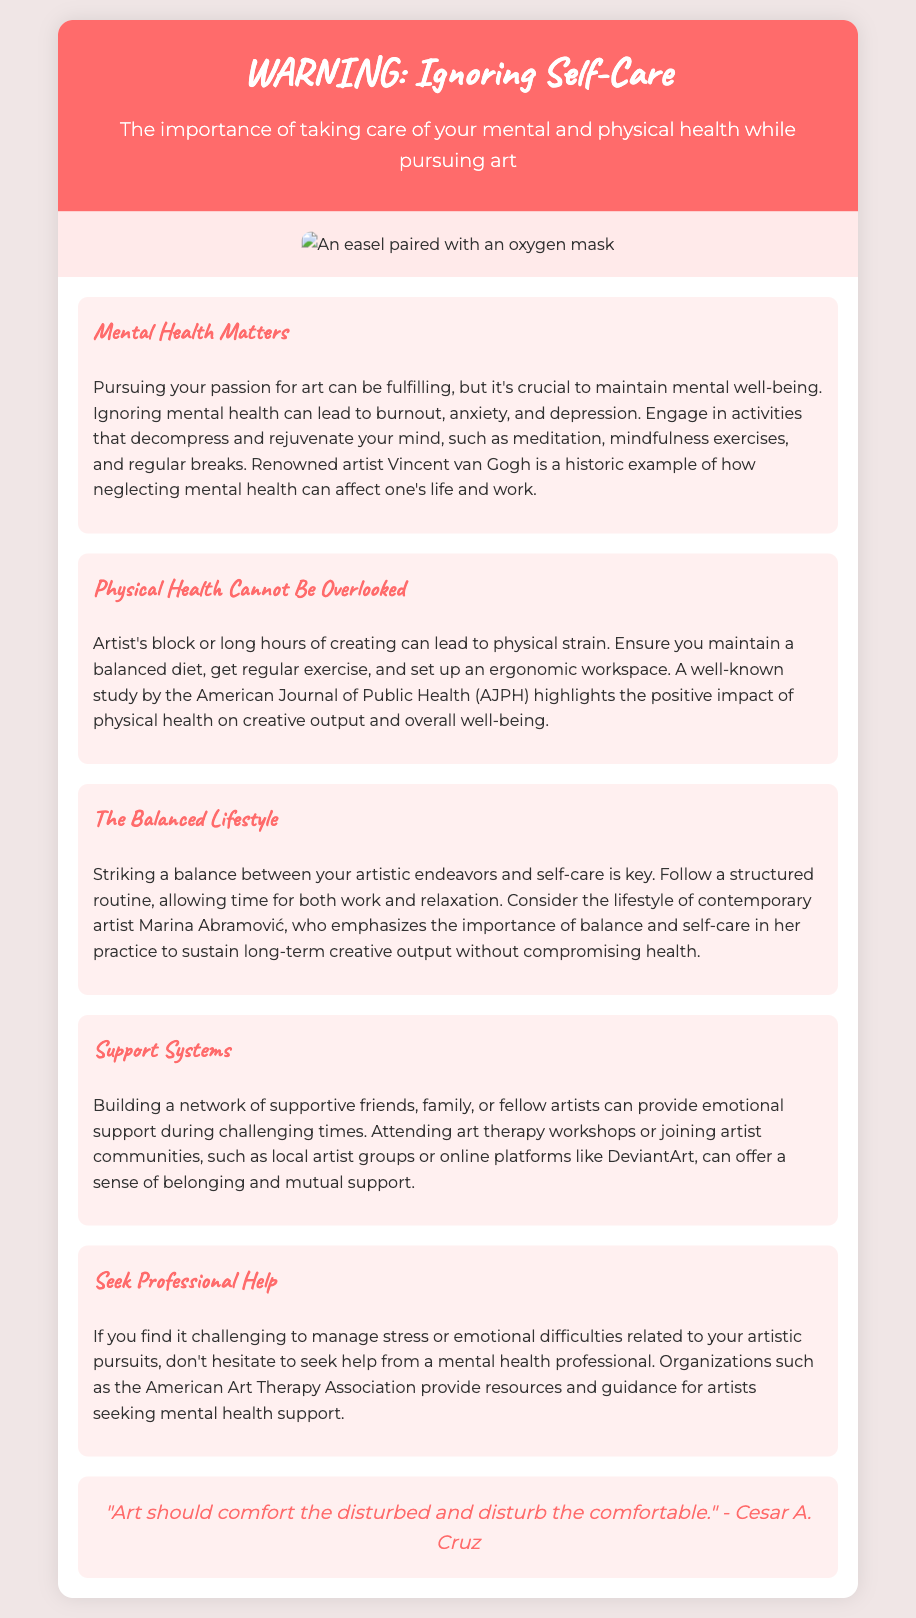What is the title of the document? The title of the document is indicated in the header section.
Answer: WARNING: Ignoring Self-Care Who is quoted in the document? The quote in the document attributes a statement to a specific individual.
Answer: Cesar A. Cruz What is emphasized as essential for mental health? The document discusses activities that help with mental well-being.
Answer: Meditation Name one contemporary artist mentioned. The document references a contemporary artist known for self-care in her practice.
Answer: Marina Abramović What health aspect is mentioned alongside mental health? The document discusses the importance of another health area in conjunction with mental health.
Answer: Physical health What should you seek if facing emotional difficulties? The document suggests an action to take when managing stress related to artistic pursuits.
Answer: Professional help What color is the header background? The header background color is specified in the style section.
Answer: #ff6b6b What is a suggested activity for physical well-being? The document mentions a specific lifestyle choice that supports physical health.
Answer: Regular exercise What are two suggestions for emotional support mentioned? The document highlights options available for building a support network.
Answer: Art therapy workshops, artist communities 